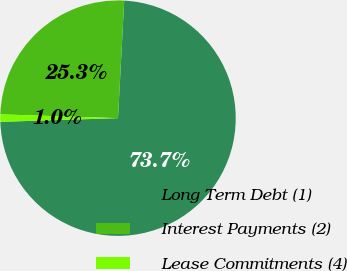<chart> <loc_0><loc_0><loc_500><loc_500><pie_chart><fcel>Long Term Debt (1)<fcel>Interest Payments (2)<fcel>Lease Commitments (4)<nl><fcel>73.66%<fcel>25.33%<fcel>1.01%<nl></chart> 